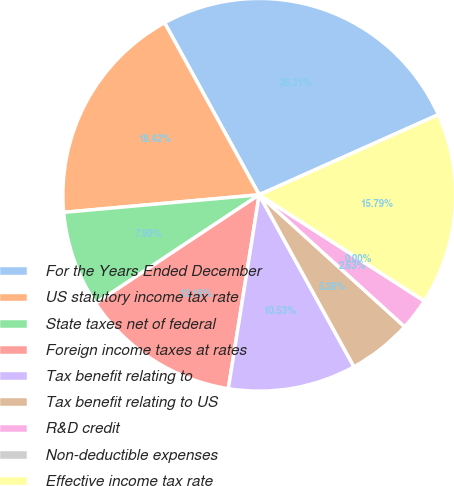Convert chart. <chart><loc_0><loc_0><loc_500><loc_500><pie_chart><fcel>For the Years Ended December<fcel>US statutory income tax rate<fcel>State taxes net of federal<fcel>Foreign income taxes at rates<fcel>Tax benefit relating to<fcel>Tax benefit relating to US<fcel>R&D credit<fcel>Non-deductible expenses<fcel>Effective income tax rate<nl><fcel>26.31%<fcel>18.42%<fcel>7.9%<fcel>13.16%<fcel>10.53%<fcel>5.26%<fcel>2.63%<fcel>0.0%<fcel>15.79%<nl></chart> 